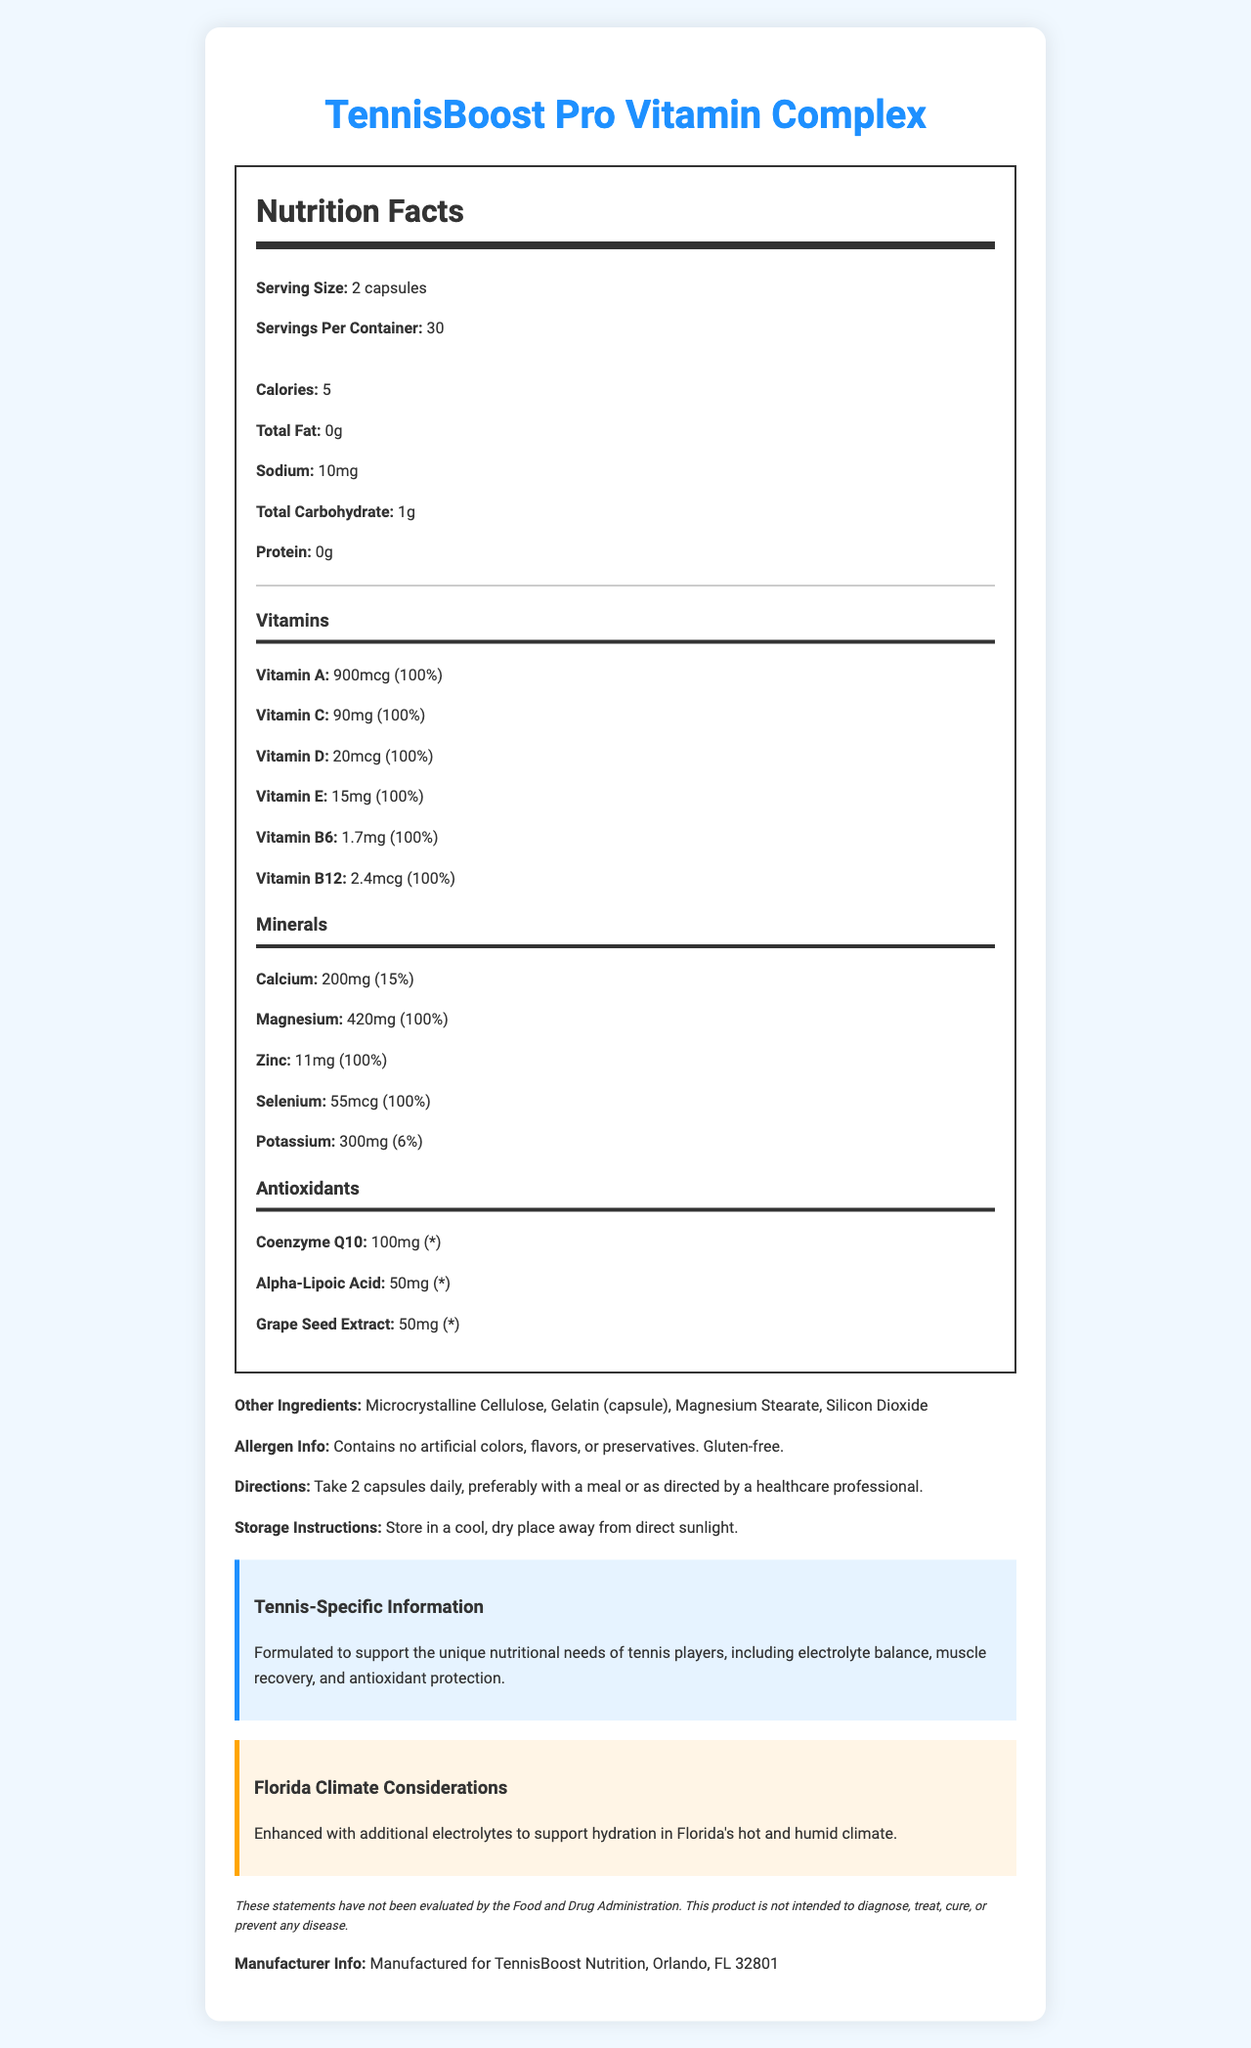what is the serving size of TennisBoost Pro Vitamin Complex? The serving size is specified as "2 capsules" in the nutrition label.
Answer: 2 capsules how many calories are in one serving? The nutrition label mentions that there are 5 calories per serving.
Answer: 5 how much Vitamin C is in one serving, and what is the percentage of the daily value? The label says Vitamin C amount is 90mg per serving, which covers 100% of the daily value.
Answer: 90mg, 100% how much calcium does one serving provide? The nutrition label shows that each serving includes 200mg of calcium.
Answer: 200mg what are the directions for taking TennisBoost Pro Vitamin Complex? The directions specify to take 2 capsules daily, preferably with a meal, or as recommended by a healthcare professional.
Answer: Take 2 capsules daily, preferably with a meal or as directed by a healthcare professional. which of the following is not listed as an ingredient? A. Microcrystalline Cellulose B. Silicon Dioxide C. Aspartame The ingredient list includes Microcrystalline Cellulose, Gelatin, Magnesium Stearate, and Silicon Dioxide, but not Aspartame.
Answer: C what additional benefit does TennisBoost Pro claim to provide for athletes in Florida's hot and humid climate? A. Extra protein B. Additional electrolytes C. Enhanced flavor The document states that the product is enhanced with additional electrolytes to support hydration in Florida's hot and humid climate.
Answer: B does this product contain gluten? The allergen information indicates that the product is gluten-free.
Answer: No is Coenzyme Q10 included in the supplement? The antioxidant section of the label lists Coenzyme Q10.
Answer: Yes is the product intended to diagnose, treat, cure, or prevent any disease? The disclaimer clearly states that the product is not intended to diagnose, treat, cure, or prevent any disease.
Answer: No summarize the main idea of the document. The document describes a vitamin supplement tailored for tennis players, highlighting its nutritional content and benefits, allergen information, and usage instructions.
Answer: TennisBoost Pro Vitamin Complex is a dietary supplement designed for tennis players. It includes essential vitamins, minerals, and antioxidants, particularly those that support hydration, muscle recovery, and antioxidant protection. It is specifically enhanced for athletes in Florida's hot and humid climate and is free from artificial colors, flavors, preservatives, and gluten. Directions and storage instructions are provided, along with a disclaimer about the product’s purpose. how many servings are there in each container? The nutrition label clearly indicates that there are 30 servings per container.
Answer: 30 how much Zinc is included per serving? According to the mineral section of the label, each serving contains 11mg of Zinc.
Answer: 11mg what is the total carbohydrate content per serving? The total carbohydrate content per serving is stated to be 1g in the nutrition label.
Answer: 1g does the product contain artificial colors, flavors, or preservatives? The allergen information section specifies that the product contains no artificial colors, flavors, or preservatives.
Answer: No what are the allergen considerations for TennisBoost Pro? The document mentions the product is gluten-free and free of artificial colors, flavors, or preservatives, but does not provide comprehensive details about all potential allergens.
Answer: Not enough information 